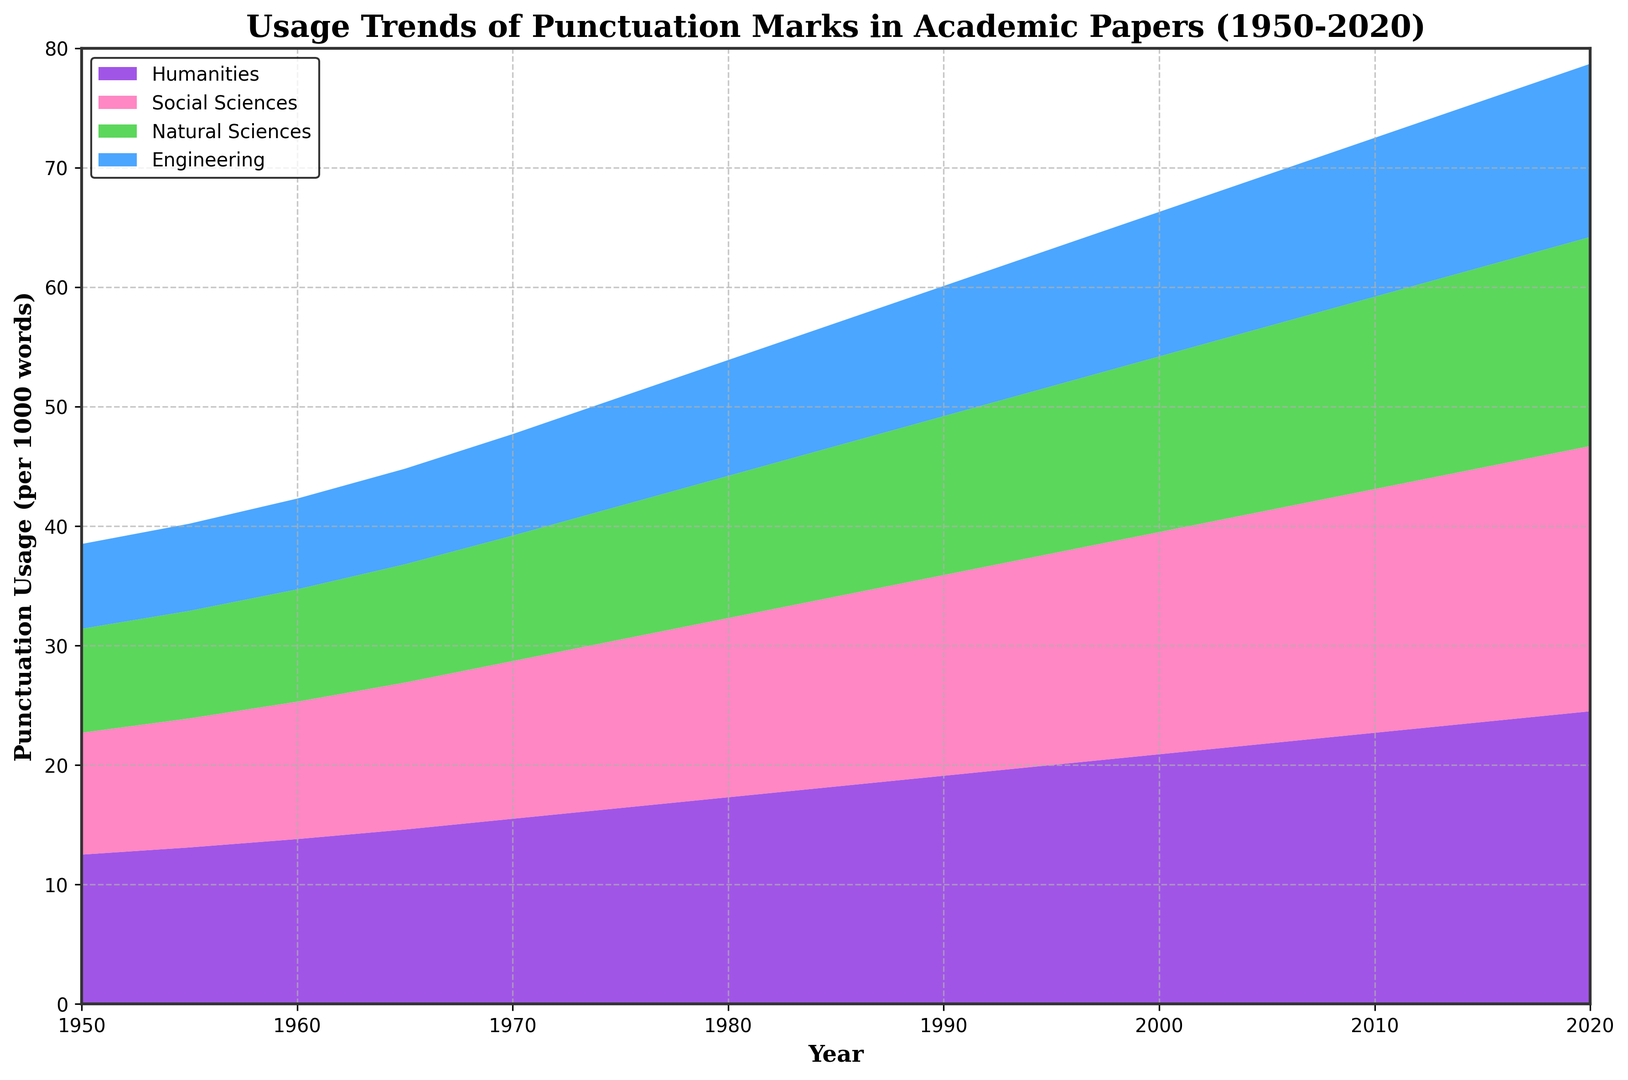What trend is observed for the usage of punctuation marks in the Humanities from 1950 to 2020? The area chart depicts the Humanities' usage trending upwards from 12.5 per 1000 words in 1950 to 24.5 per 1000 words in 2020.
Answer: Upward trend Compare the punctuation usage between Humanities and Engineering in 2020. In 2020, Humanities usage is visually higher compared to Engineering. Humanities usage is 24.5 per 1000 words, while Engineering is 14.5 per 1000 words.
Answer: Humanities higher Which discipline had the smallest increase in punctuation usage from 1950 to 2020? By observing the endpoints for each discipline, Social Sciences increased from 10.2 to 22.2, Natural Sciences from 8.7 to 17.5, Engineering from 7.1 to 14.5, and Humanities from 12.5 to 24.5. Engineering shows the smallest absolute increment (7.4).
Answer: Engineering At what point did the Social Sciences surpass the Natural Sciences in usage? By examining the area chart, Social Sciences surpassed Natural Sciences around 1970.
Answer: Around 1970 Which disciplines exhibit a visibly higher growth in punctuation usage over time? Humanities and Social Sciences show a steeper increase compared to Natural Sciences and Engineering. This is evident from the gradient of their respective areas.
Answer: Humanities, Social Sciences What is the difference in usage between Humanities and Natural Sciences in 1990? In 1990, Humanities usage is 19.1 and Natural Sciences is 13.3. The difference is 19.1 - 13.3 = 5.8 per 1000 words.
Answer: 5.8 Calculate the average punctuation usage in Engineering across all years presented. To find the average, add all the Engineering values and divide by the number of years. 7.1 + 7.3 + 7.6 + 8.0 + 8.5 + 9.1 + 9.7 + 10.3 + 10.9 + 11.5 + 12.1 + 12.7 + 13.3 + 13.9 + 14.5 = 146.5. There are 15 years, so the average is 146.5 / 15 = 9.77
Answer: 9.77 In which year did Humanities' punctuation usage first exceed 20 per 1000 words? The chart shows Humanities exceeding 20 per 1000 words in 1995.
Answer: 1995 By what year did the Humanities and Social Sciences become visually distinguishable from the other two disciplines in terms of higher punctuation usage? The Humanities and Social Sciences start to become visually distinguishable around 1980.
Answer: Around 1980 What is the most substantial increase in punctuation usage for the Natural Sciences between consecutive years? The largest increment is between 1970 and 1975. The usage increases from 10.5 to 11.2 (an increase of 0.7).
Answer: 0.7 